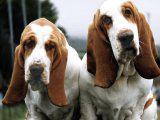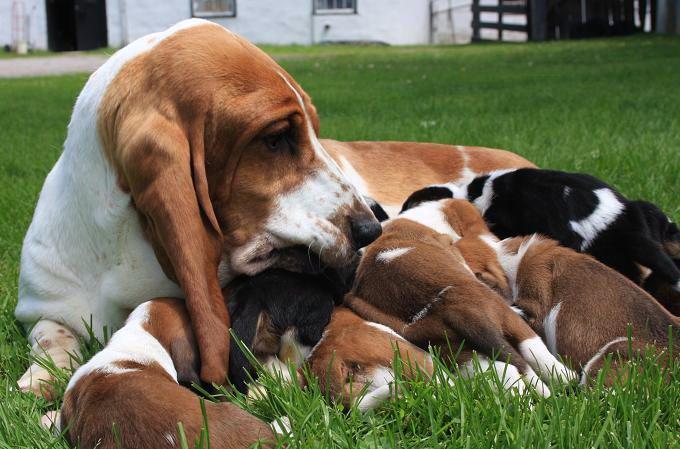The first image is the image on the left, the second image is the image on the right. For the images shown, is this caption "A single dog is standing int he grass in one of the images." true? Answer yes or no. No. The first image is the image on the left, the second image is the image on the right. For the images shown, is this caption "A sitting basset hound is interacting with one smaller basset hound on the grass." true? Answer yes or no. No. 